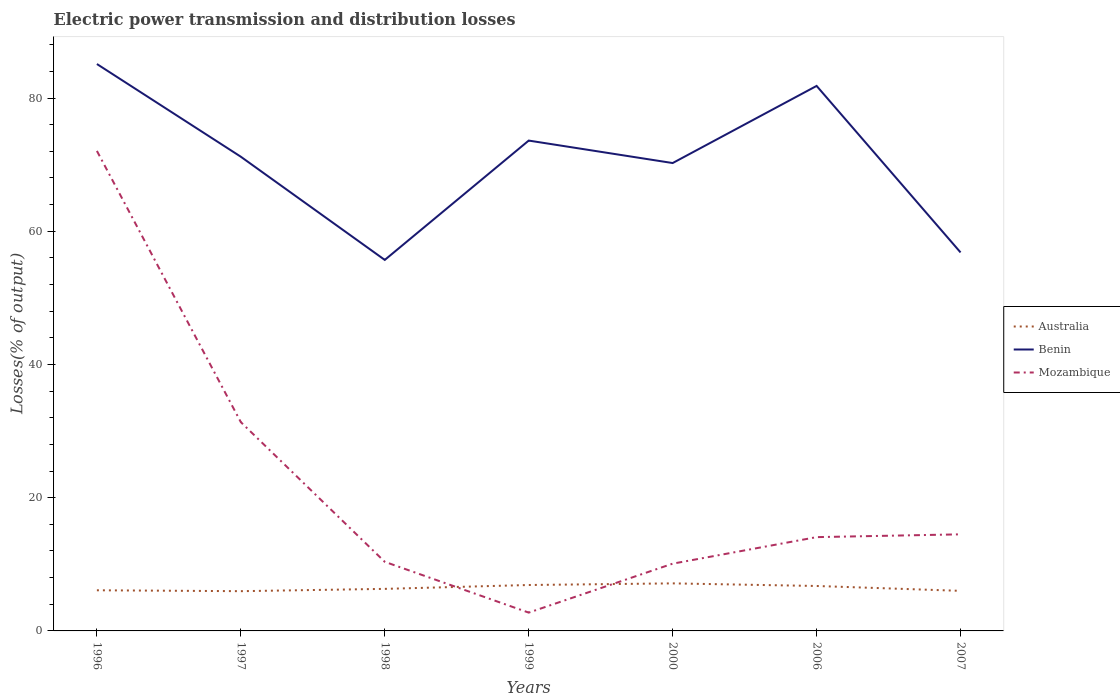How many different coloured lines are there?
Your answer should be compact. 3. Does the line corresponding to Mozambique intersect with the line corresponding to Benin?
Ensure brevity in your answer.  No. Is the number of lines equal to the number of legend labels?
Your answer should be very brief. Yes. Across all years, what is the maximum electric power transmission and distribution losses in Benin?
Your answer should be compact. 55.7. In which year was the electric power transmission and distribution losses in Benin maximum?
Make the answer very short. 1998. What is the total electric power transmission and distribution losses in Mozambique in the graph?
Your response must be concise. 17.26. What is the difference between the highest and the second highest electric power transmission and distribution losses in Mozambique?
Make the answer very short. 69.31. Is the electric power transmission and distribution losses in Mozambique strictly greater than the electric power transmission and distribution losses in Australia over the years?
Give a very brief answer. No. How many years are there in the graph?
Your answer should be compact. 7. What is the difference between two consecutive major ticks on the Y-axis?
Offer a very short reply. 20. Does the graph contain any zero values?
Keep it short and to the point. No. Does the graph contain grids?
Provide a short and direct response. No. How are the legend labels stacked?
Your response must be concise. Vertical. What is the title of the graph?
Your answer should be compact. Electric power transmission and distribution losses. What is the label or title of the X-axis?
Offer a terse response. Years. What is the label or title of the Y-axis?
Ensure brevity in your answer.  Losses(% of output). What is the Losses(% of output) in Australia in 1996?
Your answer should be compact. 6.1. What is the Losses(% of output) in Benin in 1996?
Make the answer very short. 85.11. What is the Losses(% of output) of Mozambique in 1996?
Provide a short and direct response. 72.06. What is the Losses(% of output) of Australia in 1997?
Offer a terse response. 5.97. What is the Losses(% of output) in Benin in 1997?
Provide a short and direct response. 71.19. What is the Losses(% of output) in Mozambique in 1997?
Keep it short and to the point. 31.34. What is the Losses(% of output) of Australia in 1998?
Provide a succinct answer. 6.31. What is the Losses(% of output) of Benin in 1998?
Give a very brief answer. 55.7. What is the Losses(% of output) of Mozambique in 1998?
Your answer should be very brief. 10.37. What is the Losses(% of output) of Australia in 1999?
Provide a succinct answer. 6.89. What is the Losses(% of output) in Benin in 1999?
Your answer should be very brief. 73.61. What is the Losses(% of output) in Mozambique in 1999?
Your response must be concise. 2.75. What is the Losses(% of output) of Australia in 2000?
Your response must be concise. 7.14. What is the Losses(% of output) in Benin in 2000?
Your response must be concise. 70.24. What is the Losses(% of output) of Mozambique in 2000?
Provide a succinct answer. 10.1. What is the Losses(% of output) in Australia in 2006?
Offer a terse response. 6.75. What is the Losses(% of output) in Benin in 2006?
Provide a short and direct response. 81.82. What is the Losses(% of output) in Mozambique in 2006?
Your answer should be very brief. 14.08. What is the Losses(% of output) of Australia in 2007?
Offer a terse response. 6.02. What is the Losses(% of output) in Benin in 2007?
Your answer should be compact. 56.82. What is the Losses(% of output) of Mozambique in 2007?
Provide a short and direct response. 14.5. Across all years, what is the maximum Losses(% of output) of Australia?
Your answer should be compact. 7.14. Across all years, what is the maximum Losses(% of output) in Benin?
Provide a short and direct response. 85.11. Across all years, what is the maximum Losses(% of output) in Mozambique?
Make the answer very short. 72.06. Across all years, what is the minimum Losses(% of output) in Australia?
Provide a short and direct response. 5.97. Across all years, what is the minimum Losses(% of output) of Benin?
Give a very brief answer. 55.7. Across all years, what is the minimum Losses(% of output) of Mozambique?
Provide a short and direct response. 2.75. What is the total Losses(% of output) in Australia in the graph?
Keep it short and to the point. 45.17. What is the total Losses(% of output) in Benin in the graph?
Provide a succinct answer. 494.47. What is the total Losses(% of output) of Mozambique in the graph?
Offer a very short reply. 155.2. What is the difference between the Losses(% of output) in Australia in 1996 and that in 1997?
Your answer should be compact. 0.13. What is the difference between the Losses(% of output) in Benin in 1996 and that in 1997?
Your answer should be compact. 13.92. What is the difference between the Losses(% of output) in Mozambique in 1996 and that in 1997?
Your answer should be compact. 40.72. What is the difference between the Losses(% of output) in Australia in 1996 and that in 1998?
Your answer should be compact. -0.21. What is the difference between the Losses(% of output) of Benin in 1996 and that in 1998?
Your answer should be very brief. 29.41. What is the difference between the Losses(% of output) of Mozambique in 1996 and that in 1998?
Provide a short and direct response. 61.69. What is the difference between the Losses(% of output) of Australia in 1996 and that in 1999?
Offer a very short reply. -0.79. What is the difference between the Losses(% of output) in Benin in 1996 and that in 1999?
Ensure brevity in your answer.  11.5. What is the difference between the Losses(% of output) of Mozambique in 1996 and that in 1999?
Ensure brevity in your answer.  69.31. What is the difference between the Losses(% of output) of Australia in 1996 and that in 2000?
Your answer should be very brief. -1.04. What is the difference between the Losses(% of output) of Benin in 1996 and that in 2000?
Offer a very short reply. 14.87. What is the difference between the Losses(% of output) in Mozambique in 1996 and that in 2000?
Your answer should be very brief. 61.96. What is the difference between the Losses(% of output) in Australia in 1996 and that in 2006?
Your response must be concise. -0.64. What is the difference between the Losses(% of output) of Benin in 1996 and that in 2006?
Make the answer very short. 3.29. What is the difference between the Losses(% of output) in Mozambique in 1996 and that in 2006?
Provide a succinct answer. 57.98. What is the difference between the Losses(% of output) in Australia in 1996 and that in 2007?
Offer a very short reply. 0.09. What is the difference between the Losses(% of output) in Benin in 1996 and that in 2007?
Make the answer very short. 28.29. What is the difference between the Losses(% of output) in Mozambique in 1996 and that in 2007?
Offer a very short reply. 57.56. What is the difference between the Losses(% of output) of Australia in 1997 and that in 1998?
Your answer should be compact. -0.35. What is the difference between the Losses(% of output) in Benin in 1997 and that in 1998?
Keep it short and to the point. 15.49. What is the difference between the Losses(% of output) of Mozambique in 1997 and that in 1998?
Your answer should be compact. 20.97. What is the difference between the Losses(% of output) in Australia in 1997 and that in 1999?
Offer a terse response. -0.93. What is the difference between the Losses(% of output) of Benin in 1997 and that in 1999?
Provide a succinct answer. -2.42. What is the difference between the Losses(% of output) in Mozambique in 1997 and that in 1999?
Your answer should be compact. 28.59. What is the difference between the Losses(% of output) of Australia in 1997 and that in 2000?
Make the answer very short. -1.17. What is the difference between the Losses(% of output) of Benin in 1997 and that in 2000?
Offer a very short reply. 0.95. What is the difference between the Losses(% of output) in Mozambique in 1997 and that in 2000?
Ensure brevity in your answer.  21.25. What is the difference between the Losses(% of output) in Australia in 1997 and that in 2006?
Offer a very short reply. -0.78. What is the difference between the Losses(% of output) in Benin in 1997 and that in 2006?
Offer a very short reply. -10.63. What is the difference between the Losses(% of output) of Mozambique in 1997 and that in 2006?
Make the answer very short. 17.26. What is the difference between the Losses(% of output) in Australia in 1997 and that in 2007?
Make the answer very short. -0.05. What is the difference between the Losses(% of output) of Benin in 1997 and that in 2007?
Your response must be concise. 14.37. What is the difference between the Losses(% of output) in Mozambique in 1997 and that in 2007?
Your answer should be compact. 16.84. What is the difference between the Losses(% of output) in Australia in 1998 and that in 1999?
Your answer should be compact. -0.58. What is the difference between the Losses(% of output) in Benin in 1998 and that in 1999?
Your response must be concise. -17.91. What is the difference between the Losses(% of output) in Mozambique in 1998 and that in 1999?
Provide a short and direct response. 7.62. What is the difference between the Losses(% of output) in Australia in 1998 and that in 2000?
Your answer should be very brief. -0.83. What is the difference between the Losses(% of output) in Benin in 1998 and that in 2000?
Ensure brevity in your answer.  -14.54. What is the difference between the Losses(% of output) of Mozambique in 1998 and that in 2000?
Your response must be concise. 0.28. What is the difference between the Losses(% of output) of Australia in 1998 and that in 2006?
Offer a very short reply. -0.43. What is the difference between the Losses(% of output) of Benin in 1998 and that in 2006?
Your answer should be compact. -26.12. What is the difference between the Losses(% of output) of Mozambique in 1998 and that in 2006?
Keep it short and to the point. -3.71. What is the difference between the Losses(% of output) in Australia in 1998 and that in 2007?
Offer a terse response. 0.3. What is the difference between the Losses(% of output) of Benin in 1998 and that in 2007?
Make the answer very short. -1.12. What is the difference between the Losses(% of output) of Mozambique in 1998 and that in 2007?
Offer a very short reply. -4.13. What is the difference between the Losses(% of output) of Australia in 1999 and that in 2000?
Keep it short and to the point. -0.24. What is the difference between the Losses(% of output) in Benin in 1999 and that in 2000?
Keep it short and to the point. 3.37. What is the difference between the Losses(% of output) in Mozambique in 1999 and that in 2000?
Offer a very short reply. -7.35. What is the difference between the Losses(% of output) in Australia in 1999 and that in 2006?
Your answer should be very brief. 0.15. What is the difference between the Losses(% of output) of Benin in 1999 and that in 2006?
Your answer should be very brief. -8.21. What is the difference between the Losses(% of output) in Mozambique in 1999 and that in 2006?
Ensure brevity in your answer.  -11.33. What is the difference between the Losses(% of output) in Australia in 1999 and that in 2007?
Provide a short and direct response. 0.88. What is the difference between the Losses(% of output) in Benin in 1999 and that in 2007?
Make the answer very short. 16.79. What is the difference between the Losses(% of output) in Mozambique in 1999 and that in 2007?
Keep it short and to the point. -11.75. What is the difference between the Losses(% of output) in Australia in 2000 and that in 2006?
Make the answer very short. 0.39. What is the difference between the Losses(% of output) in Benin in 2000 and that in 2006?
Make the answer very short. -11.58. What is the difference between the Losses(% of output) of Mozambique in 2000 and that in 2006?
Ensure brevity in your answer.  -3.98. What is the difference between the Losses(% of output) in Australia in 2000 and that in 2007?
Provide a short and direct response. 1.12. What is the difference between the Losses(% of output) in Benin in 2000 and that in 2007?
Your response must be concise. 13.42. What is the difference between the Losses(% of output) of Mozambique in 2000 and that in 2007?
Provide a short and direct response. -4.4. What is the difference between the Losses(% of output) in Australia in 2006 and that in 2007?
Provide a succinct answer. 0.73. What is the difference between the Losses(% of output) in Mozambique in 2006 and that in 2007?
Your answer should be compact. -0.42. What is the difference between the Losses(% of output) in Australia in 1996 and the Losses(% of output) in Benin in 1997?
Provide a short and direct response. -65.09. What is the difference between the Losses(% of output) in Australia in 1996 and the Losses(% of output) in Mozambique in 1997?
Provide a succinct answer. -25.24. What is the difference between the Losses(% of output) of Benin in 1996 and the Losses(% of output) of Mozambique in 1997?
Make the answer very short. 53.76. What is the difference between the Losses(% of output) in Australia in 1996 and the Losses(% of output) in Benin in 1998?
Give a very brief answer. -49.59. What is the difference between the Losses(% of output) of Australia in 1996 and the Losses(% of output) of Mozambique in 1998?
Your answer should be compact. -4.27. What is the difference between the Losses(% of output) of Benin in 1996 and the Losses(% of output) of Mozambique in 1998?
Offer a terse response. 74.73. What is the difference between the Losses(% of output) of Australia in 1996 and the Losses(% of output) of Benin in 1999?
Your answer should be very brief. -67.51. What is the difference between the Losses(% of output) in Australia in 1996 and the Losses(% of output) in Mozambique in 1999?
Provide a short and direct response. 3.35. What is the difference between the Losses(% of output) of Benin in 1996 and the Losses(% of output) of Mozambique in 1999?
Your answer should be compact. 82.36. What is the difference between the Losses(% of output) of Australia in 1996 and the Losses(% of output) of Benin in 2000?
Provide a short and direct response. -64.14. What is the difference between the Losses(% of output) of Australia in 1996 and the Losses(% of output) of Mozambique in 2000?
Offer a terse response. -4. What is the difference between the Losses(% of output) in Benin in 1996 and the Losses(% of output) in Mozambique in 2000?
Offer a very short reply. 75.01. What is the difference between the Losses(% of output) in Australia in 1996 and the Losses(% of output) in Benin in 2006?
Offer a terse response. -75.72. What is the difference between the Losses(% of output) of Australia in 1996 and the Losses(% of output) of Mozambique in 2006?
Your response must be concise. -7.98. What is the difference between the Losses(% of output) of Benin in 1996 and the Losses(% of output) of Mozambique in 2006?
Offer a very short reply. 71.03. What is the difference between the Losses(% of output) in Australia in 1996 and the Losses(% of output) in Benin in 2007?
Offer a very short reply. -50.72. What is the difference between the Losses(% of output) of Australia in 1996 and the Losses(% of output) of Mozambique in 2007?
Offer a terse response. -8.4. What is the difference between the Losses(% of output) in Benin in 1996 and the Losses(% of output) in Mozambique in 2007?
Provide a succinct answer. 70.61. What is the difference between the Losses(% of output) of Australia in 1997 and the Losses(% of output) of Benin in 1998?
Make the answer very short. -49.73. What is the difference between the Losses(% of output) of Australia in 1997 and the Losses(% of output) of Mozambique in 1998?
Offer a terse response. -4.41. What is the difference between the Losses(% of output) in Benin in 1997 and the Losses(% of output) in Mozambique in 1998?
Provide a short and direct response. 60.81. What is the difference between the Losses(% of output) in Australia in 1997 and the Losses(% of output) in Benin in 1999?
Make the answer very short. -67.64. What is the difference between the Losses(% of output) of Australia in 1997 and the Losses(% of output) of Mozambique in 1999?
Ensure brevity in your answer.  3.22. What is the difference between the Losses(% of output) of Benin in 1997 and the Losses(% of output) of Mozambique in 1999?
Give a very brief answer. 68.44. What is the difference between the Losses(% of output) of Australia in 1997 and the Losses(% of output) of Benin in 2000?
Keep it short and to the point. -64.27. What is the difference between the Losses(% of output) of Australia in 1997 and the Losses(% of output) of Mozambique in 2000?
Your answer should be compact. -4.13. What is the difference between the Losses(% of output) in Benin in 1997 and the Losses(% of output) in Mozambique in 2000?
Provide a short and direct response. 61.09. What is the difference between the Losses(% of output) in Australia in 1997 and the Losses(% of output) in Benin in 2006?
Keep it short and to the point. -75.85. What is the difference between the Losses(% of output) of Australia in 1997 and the Losses(% of output) of Mozambique in 2006?
Provide a short and direct response. -8.11. What is the difference between the Losses(% of output) in Benin in 1997 and the Losses(% of output) in Mozambique in 2006?
Give a very brief answer. 57.11. What is the difference between the Losses(% of output) of Australia in 1997 and the Losses(% of output) of Benin in 2007?
Your response must be concise. -50.85. What is the difference between the Losses(% of output) of Australia in 1997 and the Losses(% of output) of Mozambique in 2007?
Keep it short and to the point. -8.53. What is the difference between the Losses(% of output) of Benin in 1997 and the Losses(% of output) of Mozambique in 2007?
Ensure brevity in your answer.  56.69. What is the difference between the Losses(% of output) in Australia in 1998 and the Losses(% of output) in Benin in 1999?
Provide a short and direct response. -67.3. What is the difference between the Losses(% of output) in Australia in 1998 and the Losses(% of output) in Mozambique in 1999?
Give a very brief answer. 3.56. What is the difference between the Losses(% of output) of Benin in 1998 and the Losses(% of output) of Mozambique in 1999?
Provide a succinct answer. 52.95. What is the difference between the Losses(% of output) of Australia in 1998 and the Losses(% of output) of Benin in 2000?
Provide a succinct answer. -63.93. What is the difference between the Losses(% of output) in Australia in 1998 and the Losses(% of output) in Mozambique in 2000?
Ensure brevity in your answer.  -3.78. What is the difference between the Losses(% of output) of Benin in 1998 and the Losses(% of output) of Mozambique in 2000?
Your answer should be very brief. 45.6. What is the difference between the Losses(% of output) in Australia in 1998 and the Losses(% of output) in Benin in 2006?
Your answer should be compact. -75.51. What is the difference between the Losses(% of output) in Australia in 1998 and the Losses(% of output) in Mozambique in 2006?
Keep it short and to the point. -7.77. What is the difference between the Losses(% of output) of Benin in 1998 and the Losses(% of output) of Mozambique in 2006?
Your answer should be compact. 41.62. What is the difference between the Losses(% of output) of Australia in 1998 and the Losses(% of output) of Benin in 2007?
Keep it short and to the point. -50.51. What is the difference between the Losses(% of output) of Australia in 1998 and the Losses(% of output) of Mozambique in 2007?
Provide a succinct answer. -8.19. What is the difference between the Losses(% of output) of Benin in 1998 and the Losses(% of output) of Mozambique in 2007?
Your answer should be very brief. 41.2. What is the difference between the Losses(% of output) of Australia in 1999 and the Losses(% of output) of Benin in 2000?
Ensure brevity in your answer.  -63.34. What is the difference between the Losses(% of output) of Australia in 1999 and the Losses(% of output) of Mozambique in 2000?
Provide a short and direct response. -3.2. What is the difference between the Losses(% of output) of Benin in 1999 and the Losses(% of output) of Mozambique in 2000?
Give a very brief answer. 63.51. What is the difference between the Losses(% of output) of Australia in 1999 and the Losses(% of output) of Benin in 2006?
Your answer should be very brief. -74.92. What is the difference between the Losses(% of output) of Australia in 1999 and the Losses(% of output) of Mozambique in 2006?
Your response must be concise. -7.19. What is the difference between the Losses(% of output) of Benin in 1999 and the Losses(% of output) of Mozambique in 2006?
Your answer should be compact. 59.53. What is the difference between the Losses(% of output) in Australia in 1999 and the Losses(% of output) in Benin in 2007?
Your response must be concise. -49.92. What is the difference between the Losses(% of output) of Australia in 1999 and the Losses(% of output) of Mozambique in 2007?
Your response must be concise. -7.61. What is the difference between the Losses(% of output) in Benin in 1999 and the Losses(% of output) in Mozambique in 2007?
Provide a succinct answer. 59.11. What is the difference between the Losses(% of output) of Australia in 2000 and the Losses(% of output) of Benin in 2006?
Provide a succinct answer. -74.68. What is the difference between the Losses(% of output) in Australia in 2000 and the Losses(% of output) in Mozambique in 2006?
Give a very brief answer. -6.94. What is the difference between the Losses(% of output) of Benin in 2000 and the Losses(% of output) of Mozambique in 2006?
Provide a short and direct response. 56.16. What is the difference between the Losses(% of output) in Australia in 2000 and the Losses(% of output) in Benin in 2007?
Your answer should be very brief. -49.68. What is the difference between the Losses(% of output) of Australia in 2000 and the Losses(% of output) of Mozambique in 2007?
Ensure brevity in your answer.  -7.36. What is the difference between the Losses(% of output) in Benin in 2000 and the Losses(% of output) in Mozambique in 2007?
Provide a succinct answer. 55.74. What is the difference between the Losses(% of output) in Australia in 2006 and the Losses(% of output) in Benin in 2007?
Keep it short and to the point. -50.07. What is the difference between the Losses(% of output) in Australia in 2006 and the Losses(% of output) in Mozambique in 2007?
Your answer should be compact. -7.75. What is the difference between the Losses(% of output) of Benin in 2006 and the Losses(% of output) of Mozambique in 2007?
Your answer should be very brief. 67.32. What is the average Losses(% of output) of Australia per year?
Keep it short and to the point. 6.45. What is the average Losses(% of output) in Benin per year?
Keep it short and to the point. 70.64. What is the average Losses(% of output) of Mozambique per year?
Your answer should be very brief. 22.17. In the year 1996, what is the difference between the Losses(% of output) in Australia and Losses(% of output) in Benin?
Give a very brief answer. -79.01. In the year 1996, what is the difference between the Losses(% of output) in Australia and Losses(% of output) in Mozambique?
Make the answer very short. -65.96. In the year 1996, what is the difference between the Losses(% of output) of Benin and Losses(% of output) of Mozambique?
Your response must be concise. 13.05. In the year 1997, what is the difference between the Losses(% of output) in Australia and Losses(% of output) in Benin?
Offer a very short reply. -65.22. In the year 1997, what is the difference between the Losses(% of output) in Australia and Losses(% of output) in Mozambique?
Make the answer very short. -25.38. In the year 1997, what is the difference between the Losses(% of output) in Benin and Losses(% of output) in Mozambique?
Make the answer very short. 39.84. In the year 1998, what is the difference between the Losses(% of output) in Australia and Losses(% of output) in Benin?
Your answer should be compact. -49.38. In the year 1998, what is the difference between the Losses(% of output) of Australia and Losses(% of output) of Mozambique?
Keep it short and to the point. -4.06. In the year 1998, what is the difference between the Losses(% of output) of Benin and Losses(% of output) of Mozambique?
Your response must be concise. 45.32. In the year 1999, what is the difference between the Losses(% of output) of Australia and Losses(% of output) of Benin?
Provide a succinct answer. -66.72. In the year 1999, what is the difference between the Losses(% of output) of Australia and Losses(% of output) of Mozambique?
Give a very brief answer. 4.14. In the year 1999, what is the difference between the Losses(% of output) of Benin and Losses(% of output) of Mozambique?
Your response must be concise. 70.86. In the year 2000, what is the difference between the Losses(% of output) of Australia and Losses(% of output) of Benin?
Ensure brevity in your answer.  -63.1. In the year 2000, what is the difference between the Losses(% of output) in Australia and Losses(% of output) in Mozambique?
Provide a succinct answer. -2.96. In the year 2000, what is the difference between the Losses(% of output) of Benin and Losses(% of output) of Mozambique?
Your answer should be compact. 60.14. In the year 2006, what is the difference between the Losses(% of output) of Australia and Losses(% of output) of Benin?
Give a very brief answer. -75.07. In the year 2006, what is the difference between the Losses(% of output) in Australia and Losses(% of output) in Mozambique?
Offer a very short reply. -7.33. In the year 2006, what is the difference between the Losses(% of output) in Benin and Losses(% of output) in Mozambique?
Your response must be concise. 67.74. In the year 2007, what is the difference between the Losses(% of output) of Australia and Losses(% of output) of Benin?
Your answer should be very brief. -50.8. In the year 2007, what is the difference between the Losses(% of output) in Australia and Losses(% of output) in Mozambique?
Provide a succinct answer. -8.48. In the year 2007, what is the difference between the Losses(% of output) in Benin and Losses(% of output) in Mozambique?
Your answer should be very brief. 42.32. What is the ratio of the Losses(% of output) in Australia in 1996 to that in 1997?
Offer a terse response. 1.02. What is the ratio of the Losses(% of output) of Benin in 1996 to that in 1997?
Make the answer very short. 1.2. What is the ratio of the Losses(% of output) of Mozambique in 1996 to that in 1997?
Your response must be concise. 2.3. What is the ratio of the Losses(% of output) of Australia in 1996 to that in 1998?
Your response must be concise. 0.97. What is the ratio of the Losses(% of output) in Benin in 1996 to that in 1998?
Provide a succinct answer. 1.53. What is the ratio of the Losses(% of output) of Mozambique in 1996 to that in 1998?
Provide a succinct answer. 6.95. What is the ratio of the Losses(% of output) of Australia in 1996 to that in 1999?
Your response must be concise. 0.89. What is the ratio of the Losses(% of output) in Benin in 1996 to that in 1999?
Offer a terse response. 1.16. What is the ratio of the Losses(% of output) in Mozambique in 1996 to that in 1999?
Your response must be concise. 26.21. What is the ratio of the Losses(% of output) of Australia in 1996 to that in 2000?
Ensure brevity in your answer.  0.85. What is the ratio of the Losses(% of output) of Benin in 1996 to that in 2000?
Make the answer very short. 1.21. What is the ratio of the Losses(% of output) of Mozambique in 1996 to that in 2000?
Provide a succinct answer. 7.14. What is the ratio of the Losses(% of output) of Australia in 1996 to that in 2006?
Keep it short and to the point. 0.9. What is the ratio of the Losses(% of output) in Benin in 1996 to that in 2006?
Provide a succinct answer. 1.04. What is the ratio of the Losses(% of output) in Mozambique in 1996 to that in 2006?
Your answer should be compact. 5.12. What is the ratio of the Losses(% of output) in Australia in 1996 to that in 2007?
Give a very brief answer. 1.01. What is the ratio of the Losses(% of output) in Benin in 1996 to that in 2007?
Ensure brevity in your answer.  1.5. What is the ratio of the Losses(% of output) of Mozambique in 1996 to that in 2007?
Your answer should be compact. 4.97. What is the ratio of the Losses(% of output) of Australia in 1997 to that in 1998?
Keep it short and to the point. 0.95. What is the ratio of the Losses(% of output) of Benin in 1997 to that in 1998?
Keep it short and to the point. 1.28. What is the ratio of the Losses(% of output) of Mozambique in 1997 to that in 1998?
Offer a very short reply. 3.02. What is the ratio of the Losses(% of output) in Australia in 1997 to that in 1999?
Offer a terse response. 0.87. What is the ratio of the Losses(% of output) of Benin in 1997 to that in 1999?
Provide a short and direct response. 0.97. What is the ratio of the Losses(% of output) in Mozambique in 1997 to that in 1999?
Provide a short and direct response. 11.4. What is the ratio of the Losses(% of output) in Australia in 1997 to that in 2000?
Your answer should be very brief. 0.84. What is the ratio of the Losses(% of output) in Benin in 1997 to that in 2000?
Your answer should be compact. 1.01. What is the ratio of the Losses(% of output) in Mozambique in 1997 to that in 2000?
Make the answer very short. 3.1. What is the ratio of the Losses(% of output) in Australia in 1997 to that in 2006?
Your response must be concise. 0.88. What is the ratio of the Losses(% of output) in Benin in 1997 to that in 2006?
Your answer should be very brief. 0.87. What is the ratio of the Losses(% of output) of Mozambique in 1997 to that in 2006?
Your answer should be compact. 2.23. What is the ratio of the Losses(% of output) in Benin in 1997 to that in 2007?
Your answer should be very brief. 1.25. What is the ratio of the Losses(% of output) in Mozambique in 1997 to that in 2007?
Offer a terse response. 2.16. What is the ratio of the Losses(% of output) of Australia in 1998 to that in 1999?
Your response must be concise. 0.92. What is the ratio of the Losses(% of output) of Benin in 1998 to that in 1999?
Give a very brief answer. 0.76. What is the ratio of the Losses(% of output) in Mozambique in 1998 to that in 1999?
Give a very brief answer. 3.77. What is the ratio of the Losses(% of output) of Australia in 1998 to that in 2000?
Your answer should be compact. 0.88. What is the ratio of the Losses(% of output) of Benin in 1998 to that in 2000?
Keep it short and to the point. 0.79. What is the ratio of the Losses(% of output) in Mozambique in 1998 to that in 2000?
Your response must be concise. 1.03. What is the ratio of the Losses(% of output) in Australia in 1998 to that in 2006?
Your answer should be very brief. 0.94. What is the ratio of the Losses(% of output) of Benin in 1998 to that in 2006?
Your response must be concise. 0.68. What is the ratio of the Losses(% of output) of Mozambique in 1998 to that in 2006?
Offer a very short reply. 0.74. What is the ratio of the Losses(% of output) of Australia in 1998 to that in 2007?
Keep it short and to the point. 1.05. What is the ratio of the Losses(% of output) of Benin in 1998 to that in 2007?
Your answer should be compact. 0.98. What is the ratio of the Losses(% of output) of Mozambique in 1998 to that in 2007?
Your answer should be compact. 0.72. What is the ratio of the Losses(% of output) of Australia in 1999 to that in 2000?
Ensure brevity in your answer.  0.97. What is the ratio of the Losses(% of output) of Benin in 1999 to that in 2000?
Offer a terse response. 1.05. What is the ratio of the Losses(% of output) of Mozambique in 1999 to that in 2000?
Your response must be concise. 0.27. What is the ratio of the Losses(% of output) of Australia in 1999 to that in 2006?
Ensure brevity in your answer.  1.02. What is the ratio of the Losses(% of output) of Benin in 1999 to that in 2006?
Offer a terse response. 0.9. What is the ratio of the Losses(% of output) of Mozambique in 1999 to that in 2006?
Your answer should be very brief. 0.2. What is the ratio of the Losses(% of output) in Australia in 1999 to that in 2007?
Give a very brief answer. 1.15. What is the ratio of the Losses(% of output) of Benin in 1999 to that in 2007?
Your answer should be compact. 1.3. What is the ratio of the Losses(% of output) of Mozambique in 1999 to that in 2007?
Offer a terse response. 0.19. What is the ratio of the Losses(% of output) of Australia in 2000 to that in 2006?
Keep it short and to the point. 1.06. What is the ratio of the Losses(% of output) of Benin in 2000 to that in 2006?
Keep it short and to the point. 0.86. What is the ratio of the Losses(% of output) in Mozambique in 2000 to that in 2006?
Your answer should be compact. 0.72. What is the ratio of the Losses(% of output) of Australia in 2000 to that in 2007?
Offer a terse response. 1.19. What is the ratio of the Losses(% of output) in Benin in 2000 to that in 2007?
Offer a very short reply. 1.24. What is the ratio of the Losses(% of output) of Mozambique in 2000 to that in 2007?
Give a very brief answer. 0.7. What is the ratio of the Losses(% of output) in Australia in 2006 to that in 2007?
Ensure brevity in your answer.  1.12. What is the ratio of the Losses(% of output) of Benin in 2006 to that in 2007?
Keep it short and to the point. 1.44. What is the ratio of the Losses(% of output) of Mozambique in 2006 to that in 2007?
Keep it short and to the point. 0.97. What is the difference between the highest and the second highest Losses(% of output) in Australia?
Your answer should be compact. 0.24. What is the difference between the highest and the second highest Losses(% of output) of Benin?
Keep it short and to the point. 3.29. What is the difference between the highest and the second highest Losses(% of output) of Mozambique?
Keep it short and to the point. 40.72. What is the difference between the highest and the lowest Losses(% of output) in Australia?
Your response must be concise. 1.17. What is the difference between the highest and the lowest Losses(% of output) of Benin?
Provide a succinct answer. 29.41. What is the difference between the highest and the lowest Losses(% of output) of Mozambique?
Give a very brief answer. 69.31. 